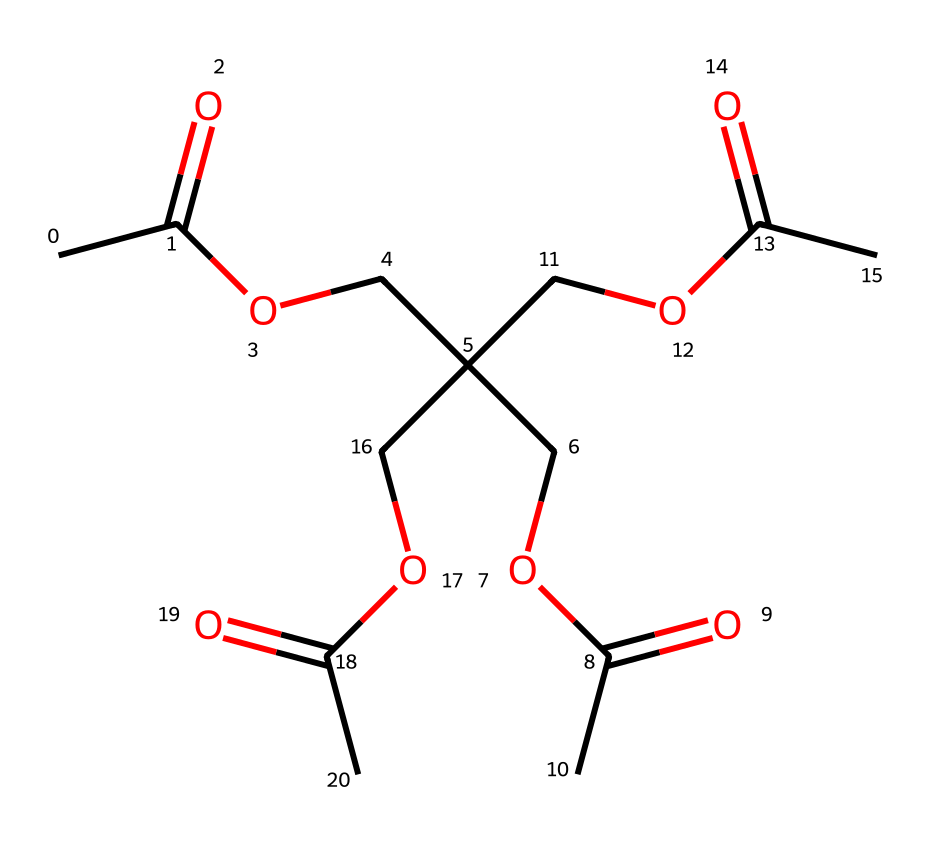What is the main functional group present in this chemical? The structure shows multiple ester groups given by the -COOC- units throughout. Esters typically arise from the reaction of alcohols and acids.
Answer: ester How many carbon atoms are in the chemical? By counting the carbon atoms in the structure, we can see 12 carbon atoms in total, including those in the main chain and branches.
Answer: 12 What is the total number of oxygen atoms in the compound? The chemical consists of several -COO- groups and individual oxygen atoms as part of the ester linkages. By counting, there are 8 oxygen atoms present in the molecule.
Answer: 8 What type of reaction could this chemical undergo to form its structure? This chemical's structure suggests it results from a condensation reaction typical of esterification, where an alcohol reacts with a carboxylic acid, releasing water.
Answer: esterification What is the likely state of this chemical at room temperature? Given that this chemical comprises esters and appears to have relatively low molecular weight, it is likely to be a liquid under standard conditions at room temperature.
Answer: liquid Does this chemical have any chiral centers? Examining the structure closely, there are carbon atoms bonded to four different groups, indicating the presence of chiral centers. Specifically, there are three chiral centers in this compound.
Answer: three 